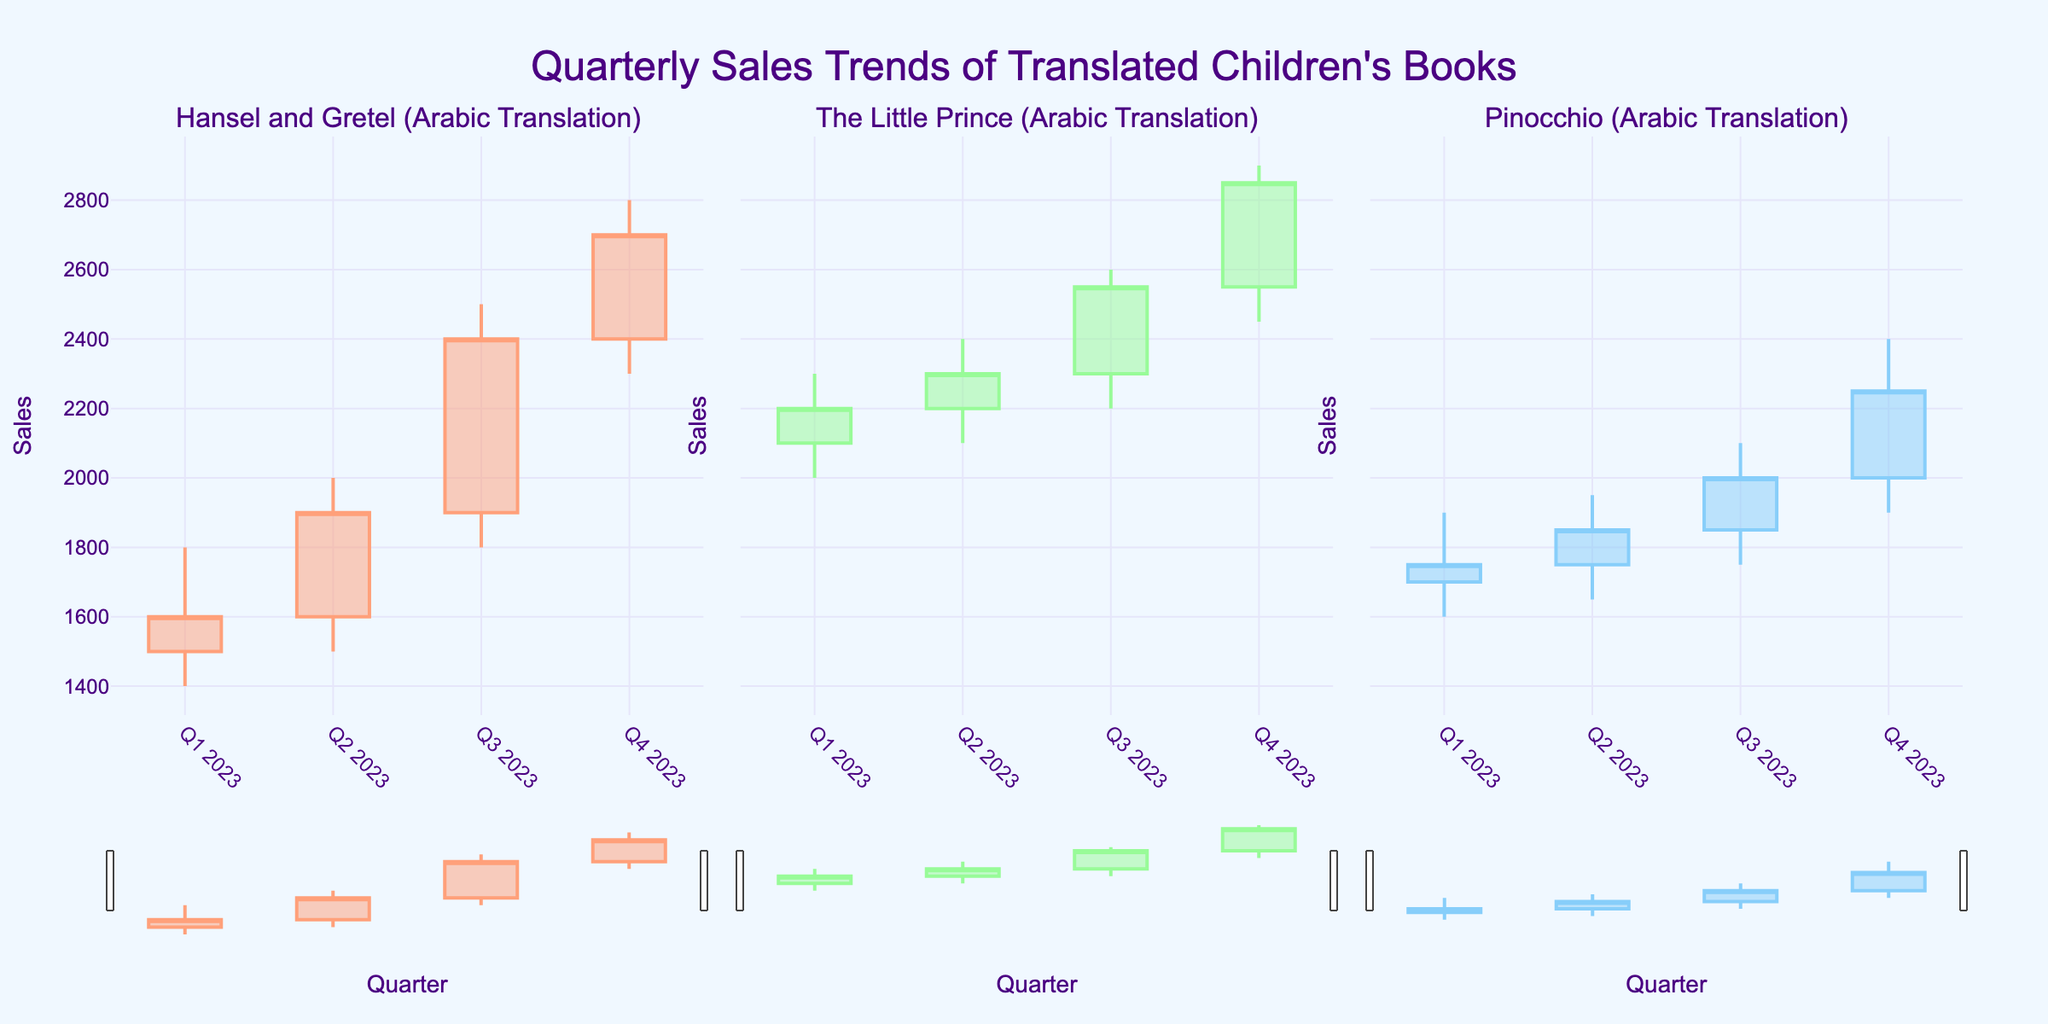What's the title of the figure? The title of the figure is displayed at the top of the plot. It reads: "Quarterly Sales Trends of Translated Children's Books".
Answer: Quarterly Sales Trends of Translated Children's Books How many children's books are tracked in the figure? The figure has three subplots, each representing a different book. The titles of the books are given as subplot titles.
Answer: Three Which book had the highest peak sales in Q3 2023? By examining the highest points in Q3 2023 for each candlestick plot, "Hansel and Gretel (Arabic Translation)" peaks at 2500.
Answer: Hansel and Gretel (Arabic Translation) What is the overall trend of sales for "The Little Prince (Arabic Translation)" from Q1 to Q4 2023? For "The Little Prince (Arabic Translation)", observe the closing prices for each quarter. The closing sales show a steady upward trend from 2200 in Q1 to 2850 in Q4.
Answer: Upward trend In which quarter did "Pinocchio (Arabic Translation)" experience the highest opening sales? Examine the opening value of each quarterly candlestick for "Pinocchio (Arabic Translation)". The highest opening value is 2000, which occurs in Q4 2023.
Answer: Q4 2023 What is the difference in the closing sales of "Hansel and Gretel (Arabic Translation)" between Q2 and Q3 2023? The closing sales for "Hansel and Gretel (Arabic Translation)" are 1900 in Q2 and 2400 in Q3. Subtract the Q2 value from the Q3 value to find the difference: 2400 - 1900 = 500.
Answer: 500 Compare the sales volatility of "Hansel and Gretel (Arabic Translation)" and "The Little Prince (Arabic Translation)" in Q3 2023? Volatility can be inferred by the range (high-low) of the candlestick. For Q3 2023, "Hansel and Gretel" has a range of 2500-1800=700, while "The Little Prince" has a range of 2600-2200=400. Therefore, "Hansel and Gretel" exhibits more volatility.
Answer: Hansel and Gretel has higher volatility How does the closing sales of "Pinocchio (Arabic Translation)" in Q1 2023 compare to its closing sales in Q4 2023? The closing sales of "Pinocchio (Arabic Translation)" in Q1 2023 is 1750 and in Q4 2023 is 2250. Comparing these values, it has increased by 500 units.
Answer: Increased by 500 Calculate the average closing sales for "The Little Prince (Arabic Translation)" across all four quarters in 2023. Here are the closing sales: Q1 (2200), Q2 (2300), Q3 (2550), Q4 (2850). The average is calculated as (2200 + 2300 + 2550 + 2850) / 4 = 2475.
Answer: 2475 